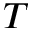<formula> <loc_0><loc_0><loc_500><loc_500>T</formula> 